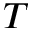<formula> <loc_0><loc_0><loc_500><loc_500>T</formula> 